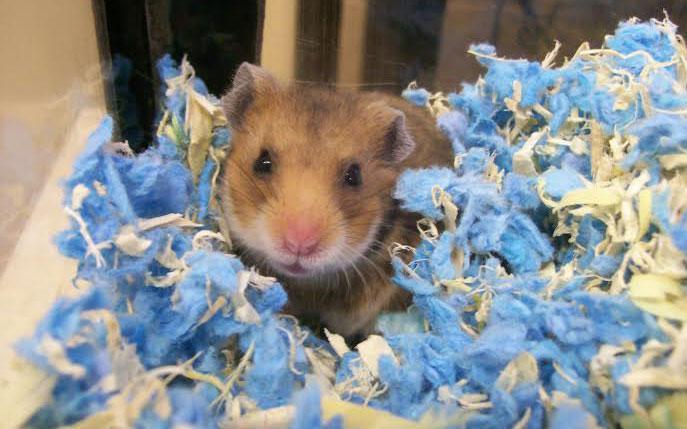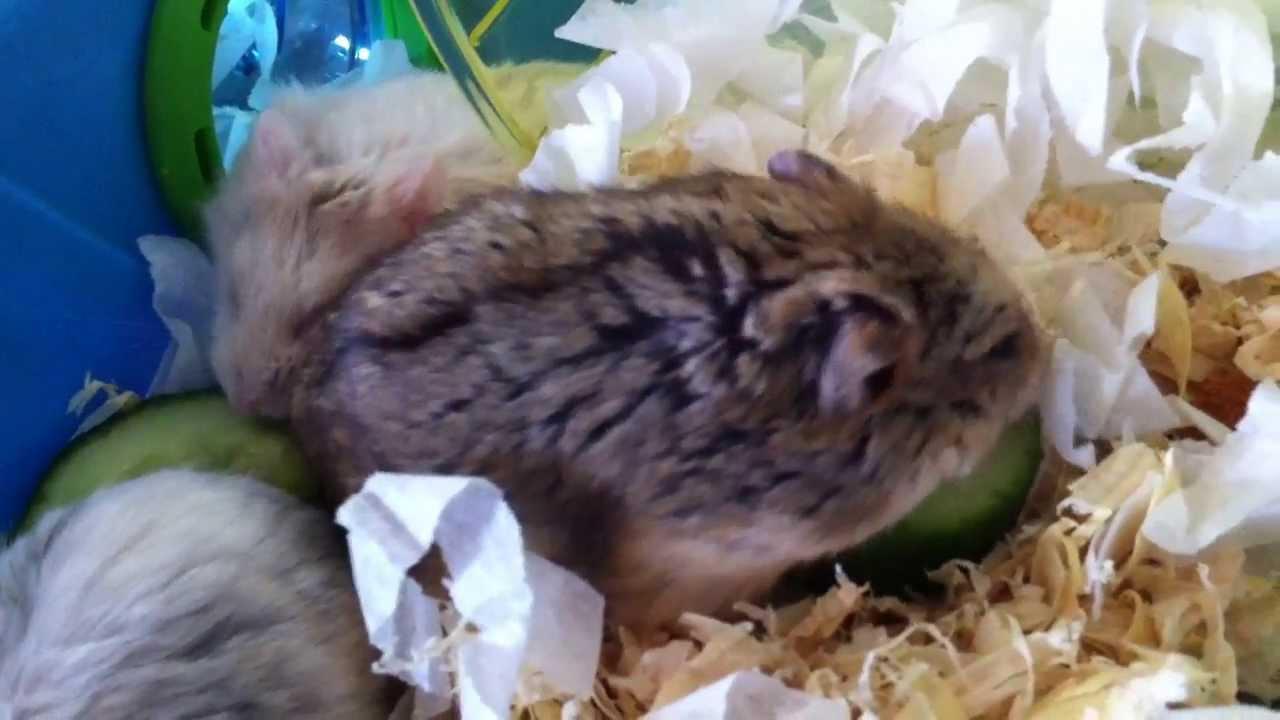The first image is the image on the left, the second image is the image on the right. Examine the images to the left and right. Is the description "There are two rodents in the image on the right." accurate? Answer yes or no. No. The first image is the image on the left, the second image is the image on the right. Evaluate the accuracy of this statement regarding the images: "The right image contains exactly two mouse-like animals posed side-by-side with heads close together, and the left image contains something round and brown that nearly fills the space.". Is it true? Answer yes or no. No. 